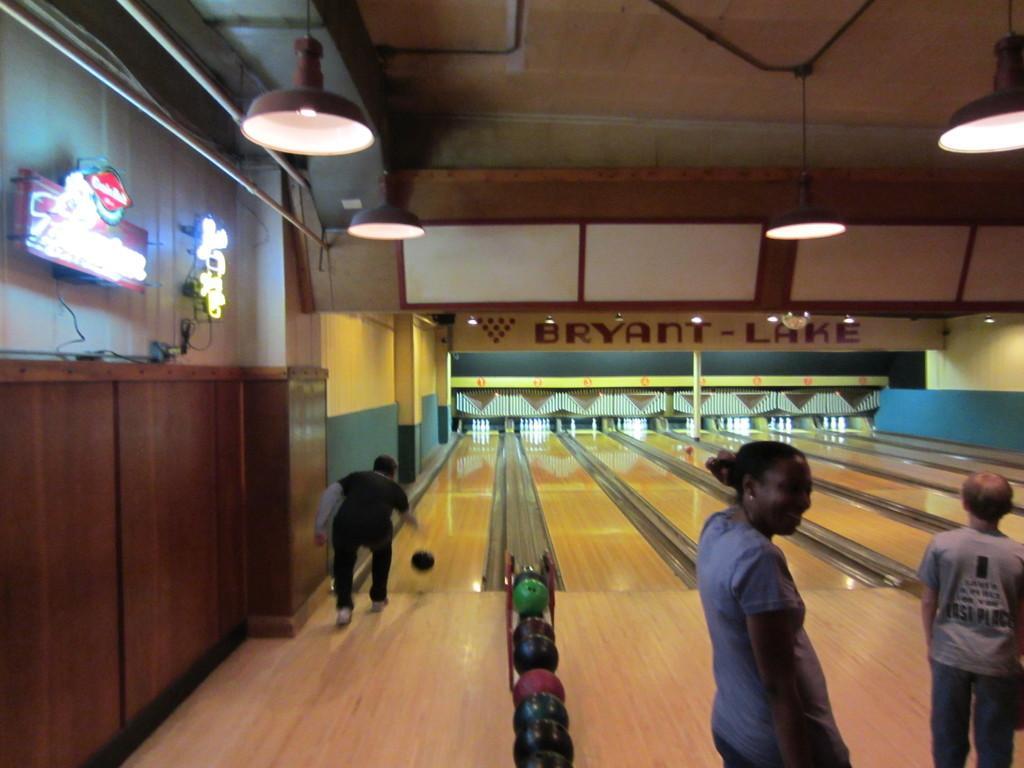Could you give a brief overview of what you see in this image? In this image there is a man on the left side who is playing the bowling game. Beside him there are balls kept on the stand. On the right side there are two persons standing on the floor. At the top there are lights which are hanged to the roof. On the left side there are lights which are attached to the wall. There are cones kept on the wooden surface which are used for the bowling game. 